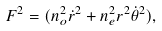Convert formula to latex. <formula><loc_0><loc_0><loc_500><loc_500>F ^ { 2 } = ( n _ { o } ^ { 2 } \dot { r } ^ { 2 } + n _ { e } ^ { 2 } r ^ { 2 } \dot { \theta } ^ { 2 } ) ,</formula> 